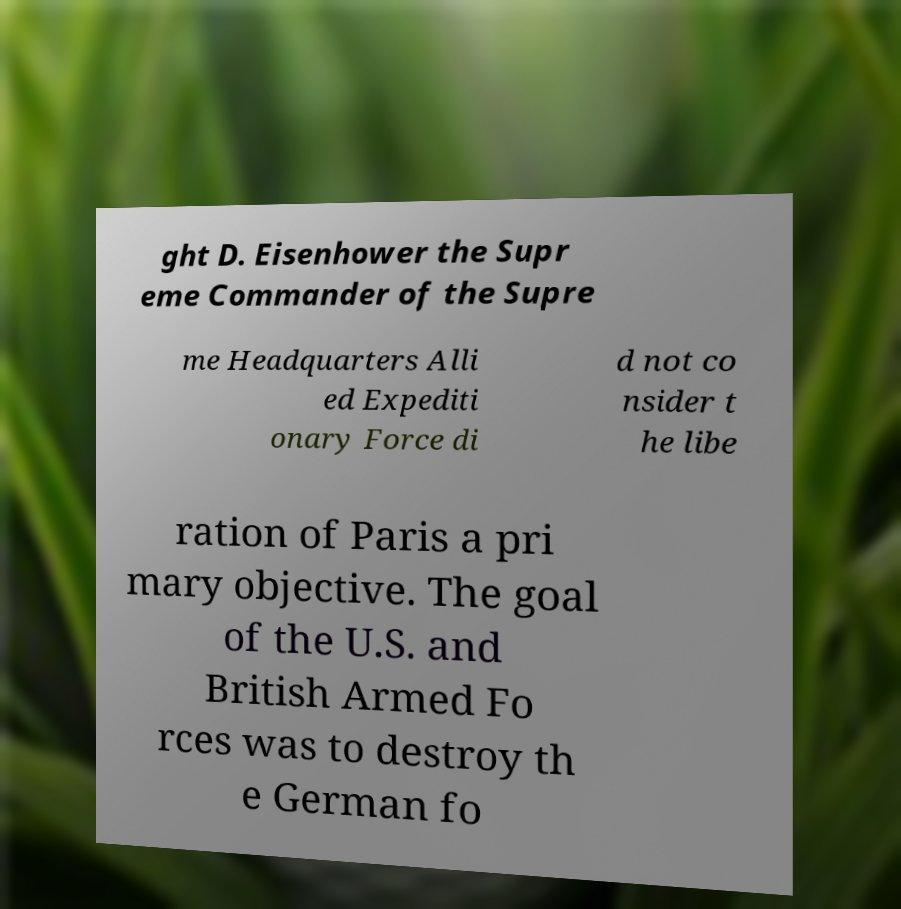Could you assist in decoding the text presented in this image and type it out clearly? ght D. Eisenhower the Supr eme Commander of the Supre me Headquarters Alli ed Expediti onary Force di d not co nsider t he libe ration of Paris a pri mary objective. The goal of the U.S. and British Armed Fo rces was to destroy th e German fo 